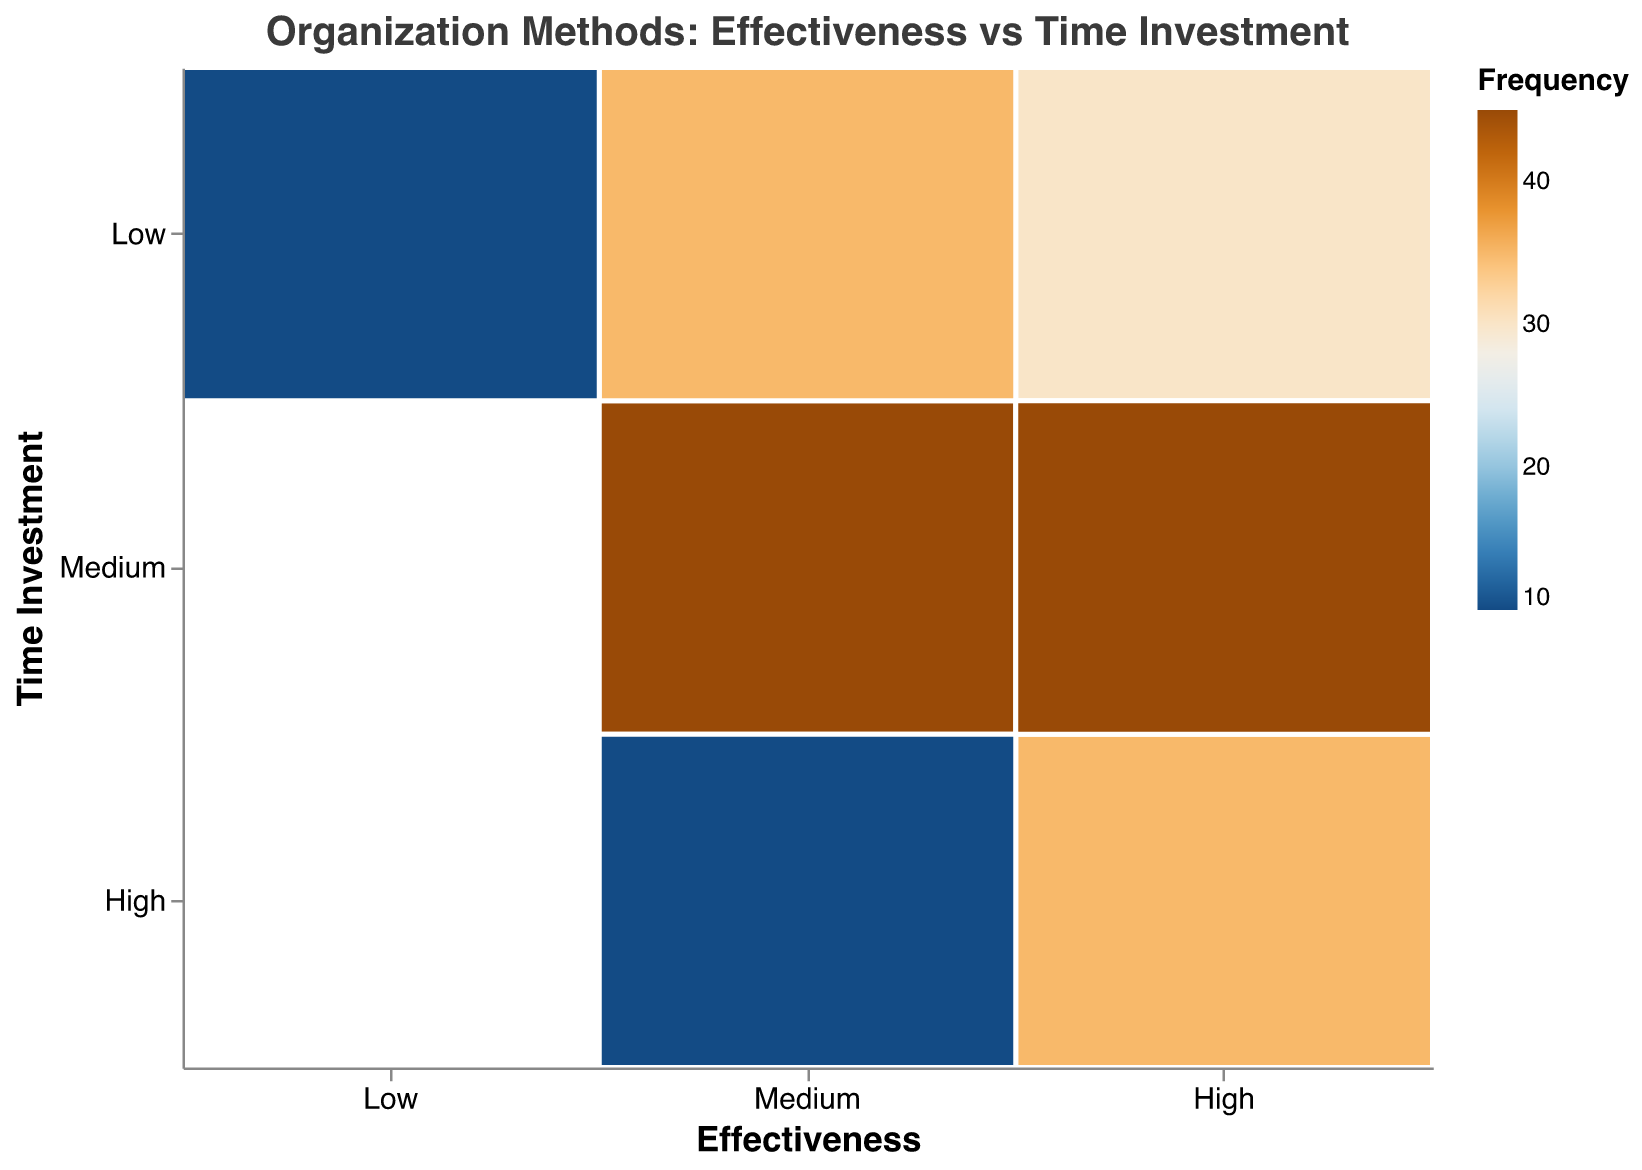What is the title of the figure? The title of the figure is typically located at the top and is a short description of what the plot represents.
Answer: Organization Methods: Effectiveness vs Time Investment How is the color of the blocks determined? The color of the blocks in the plot corresponds to the frequency of each organization method within the different combinations of effectiveness and time investment. This color scaling helps in visualizing the relative frequency of each combination.
Answer: By frequency Which combination has the highest frequency? To find this, we look for the most intense color on the plot, as this indicates the highest frequency. The combination of "Pomodoro Technique" with "Medium Effectiveness" and "Low Time Investment" stands out.
Answer: Medium Effectiveness and Low Time Investment How many organization methods fall under high effectiveness and medium time investment? We count the unique organization methods that are located in the block that represents high effectiveness and medium time investment.
Answer: 2 (Kanban Board and Cornell Note-Taking) Which effectiveness category has the most methods with low time investment? By visually inspecting the blocks under low time investment, the effectiveness category with the most blocks (or distinct methods) is identified.
Answer: Medium Effectiveness What is the sum of frequencies for methods with high effectiveness? Adding up the frequencies of all blocks under high effectiveness gives us the total number of occurrences for this category. The methods are "Digital Task Management" (30), "Bullet Journaling" (20), "Kanban Board" (15), "Cornell Note-Taking" (30), and "5S Workplace Organization" (15), so the sum is 30+20+15+30+15.
Answer: 110 Which effectiveness and time investment combination has the least frequency? By looking for the block with the most faded color (representing the smallest frequency) and combining the categories, we find "Low Effectiveness" and "Low Time Investment" to have the least frequency.
Answer: Low Effectiveness and Low Time Investment What is the average frequency for all methods with medium time investment? Summing all the frequencies under medium time investment and dividing by the number of such blocks. The methods are "Physical Filing System" (25), "Kanban Board" (15), "Time Blocking" (20), and "Cornell Note-Taking" (30), so the average is (25+15+20+30)/4.
Answer: 22.5 How does the frequency of methods with high time investment compare to those with low time investment? Comparing the total frequencies in the high time investment category to those in the low time investment category can be done by summing each. High time investments include "Bullet Journaling" (20), "5S Workplace Organization" (15), and "GTD" (10), totaling 45. Low time investments include "Digital Task Management" (30), "Pomodoro Technique" (35), and "Mind Mapping" (10), totaling 75.
Answer: Low has higher frequency 